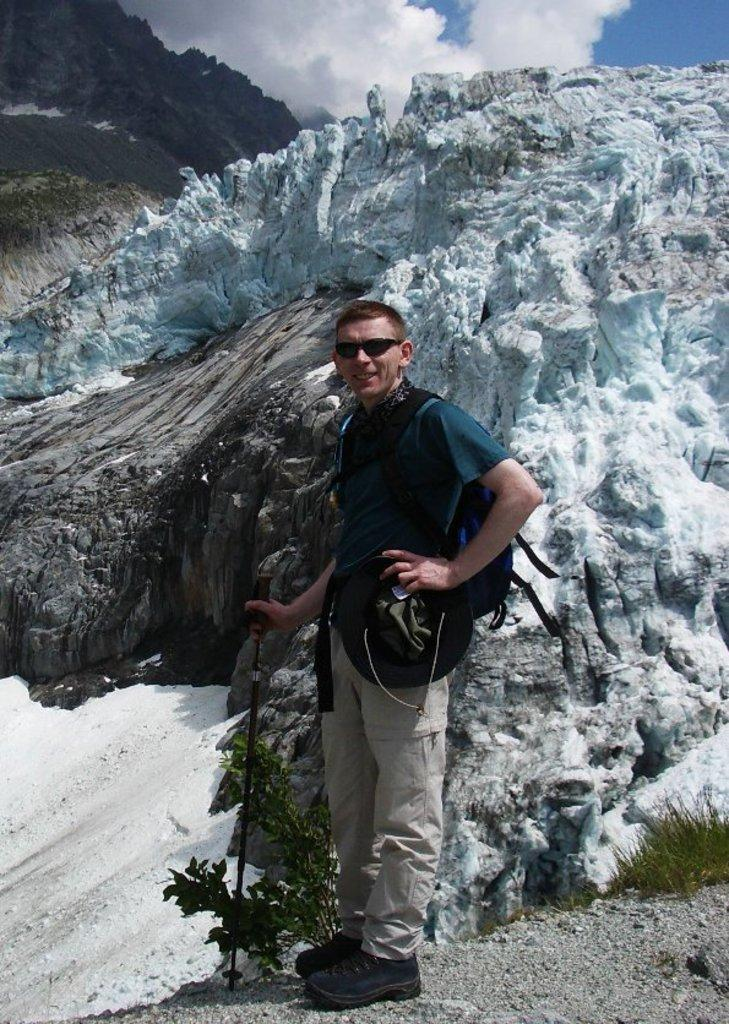What type of natural formation can be seen in the image? There are mountains in the image. What other elements are present in the image besides the mountains? There are plants and a person in the image. What is the person holding in his hand? The person is holding an object in his hand. How would you describe the sky in the image? The sky is blue and cloudy in the image. Is there a gold tent visible in the image? No, there is no tent, gold or otherwise, present in the image. Can you see a ship sailing near the mountains in the image? No, there is no ship visible in the image; it only features mountains, plants, and a person. 